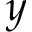<formula> <loc_0><loc_0><loc_500><loc_500>y</formula> 